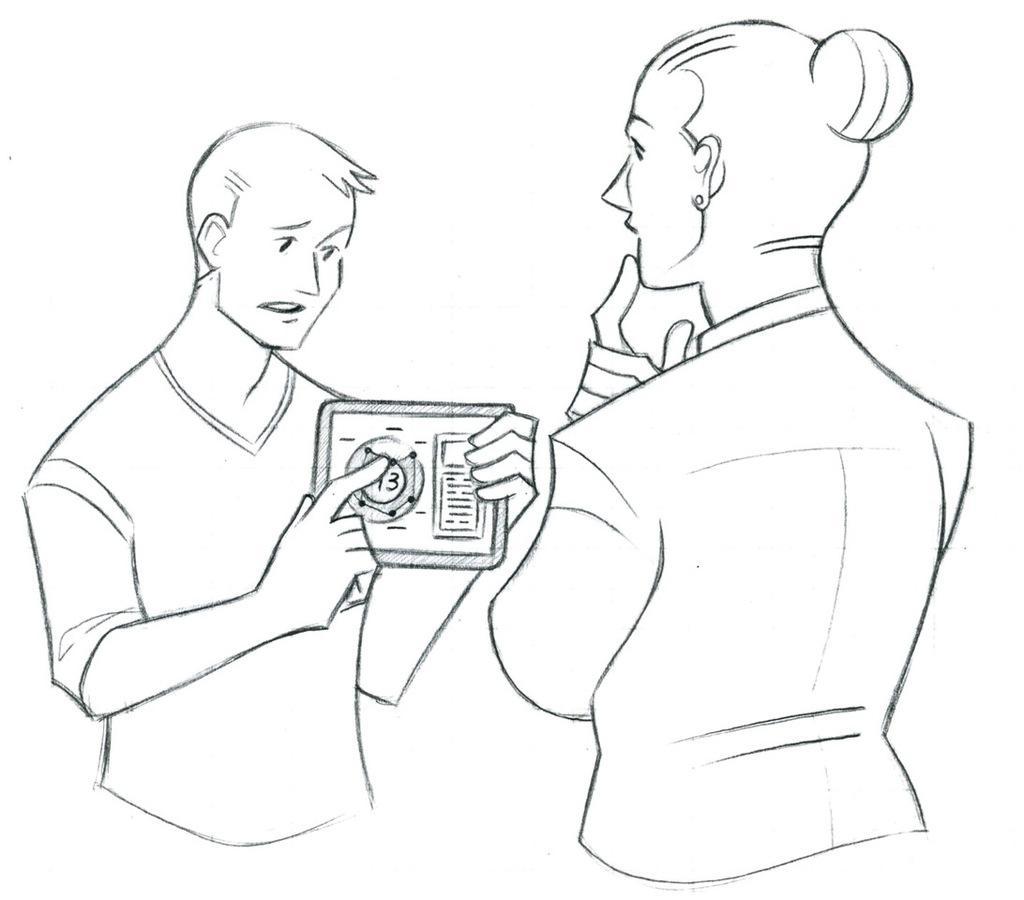Could you give a brief overview of what you see in this image? This is the drawing of a man and woman. And the man is holding something in his hand. 